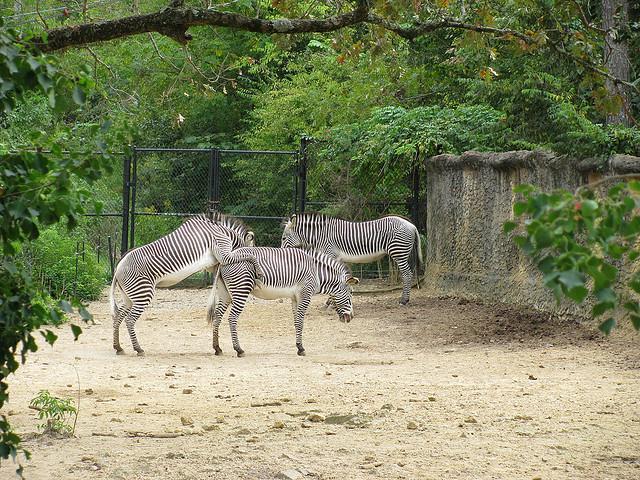How many zebras are there?
Give a very brief answer. 3. How many zebra are there?
Give a very brief answer. 3. How many animals can be seen?
Give a very brief answer. 3. How many zebras are in the photo?
Give a very brief answer. 3. How many boats are to the right of the stop sign?
Give a very brief answer. 0. 